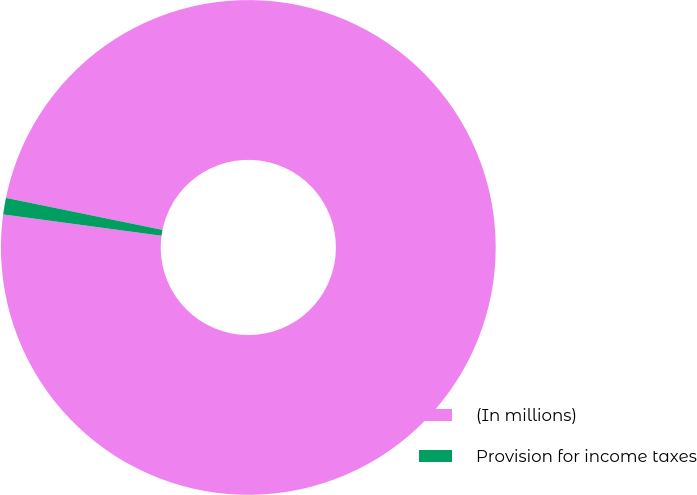<chart> <loc_0><loc_0><loc_500><loc_500><pie_chart><fcel>(In millions)<fcel>Provision for income taxes<nl><fcel>98.92%<fcel>1.08%<nl></chart> 